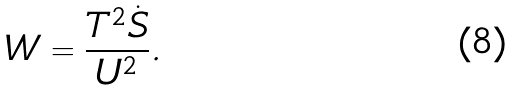Convert formula to latex. <formula><loc_0><loc_0><loc_500><loc_500>W = \frac { T ^ { 2 } \dot { S } } { U ^ { 2 } } .</formula> 